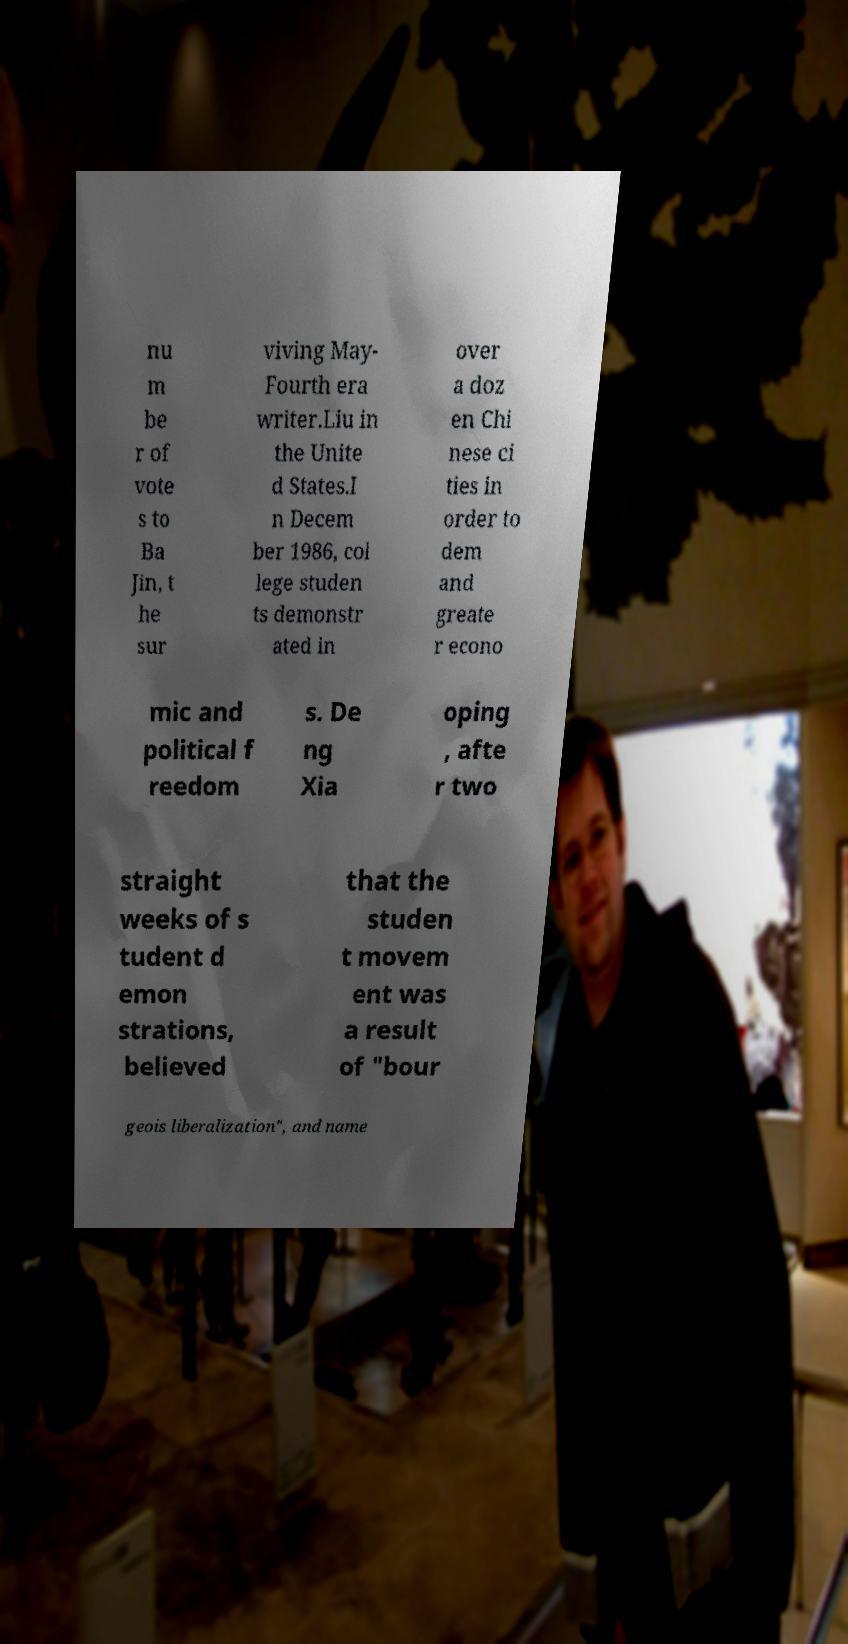There's text embedded in this image that I need extracted. Can you transcribe it verbatim? nu m be r of vote s to Ba Jin, t he sur viving May- Fourth era writer.Liu in the Unite d States.I n Decem ber 1986, col lege studen ts demonstr ated in over a doz en Chi nese ci ties in order to dem and greate r econo mic and political f reedom s. De ng Xia oping , afte r two straight weeks of s tudent d emon strations, believed that the studen t movem ent was a result of "bour geois liberalization", and name 